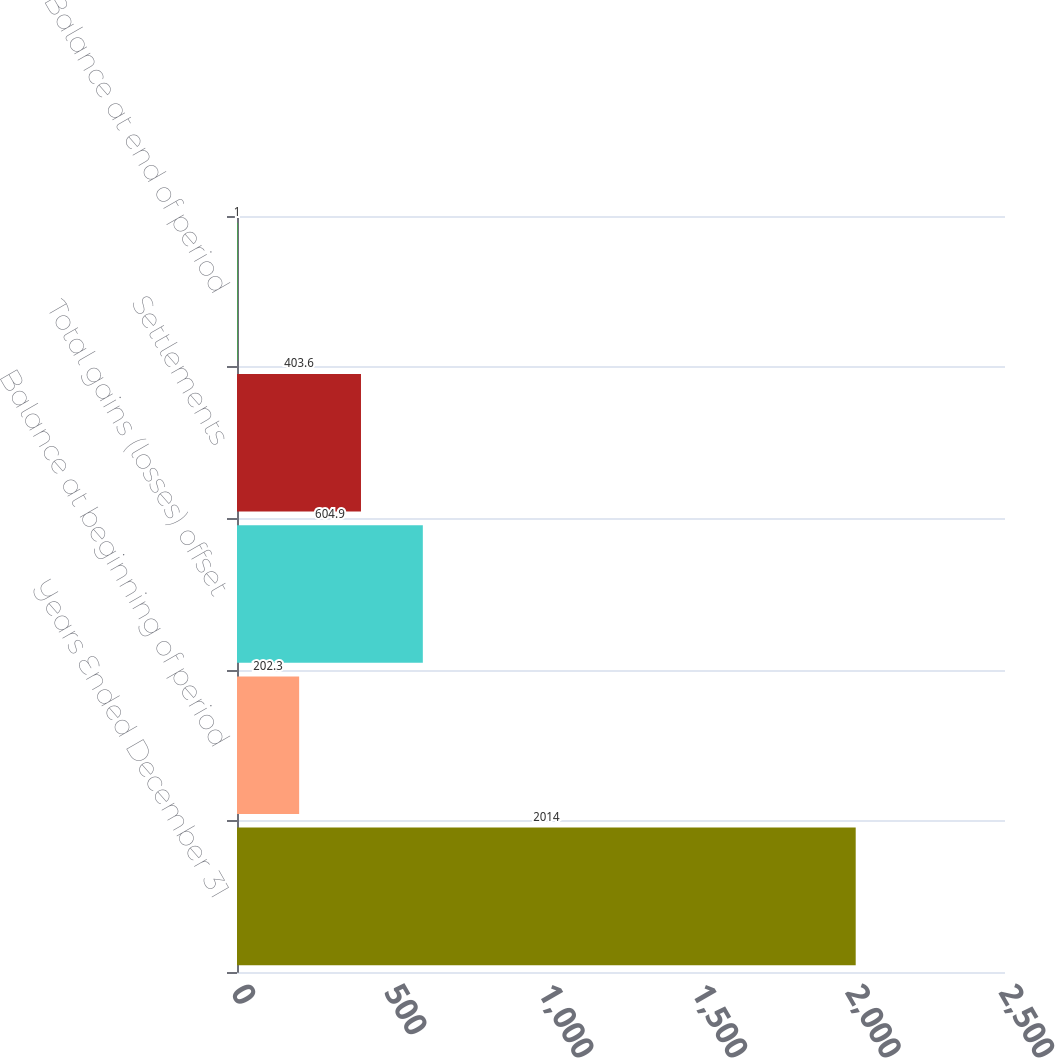<chart> <loc_0><loc_0><loc_500><loc_500><bar_chart><fcel>Years Ended December 31<fcel>Balance at beginning of period<fcel>Total gains (losses) offset<fcel>Settlements<fcel>Balance at end of period<nl><fcel>2014<fcel>202.3<fcel>604.9<fcel>403.6<fcel>1<nl></chart> 